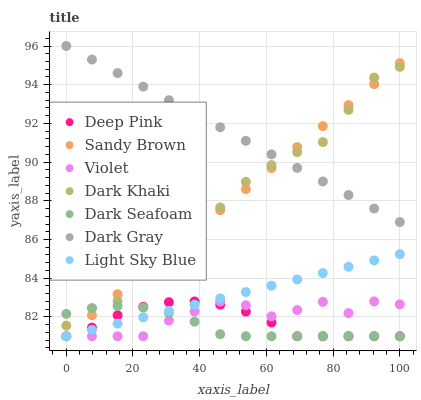Does Dark Seafoam have the minimum area under the curve?
Answer yes or no. Yes. Does Dark Gray have the maximum area under the curve?
Answer yes or no. Yes. Does Deep Pink have the minimum area under the curve?
Answer yes or no. No. Does Deep Pink have the maximum area under the curve?
Answer yes or no. No. Is Light Sky Blue the smoothest?
Answer yes or no. Yes. Is Dark Khaki the roughest?
Answer yes or no. Yes. Is Deep Pink the smoothest?
Answer yes or no. No. Is Deep Pink the roughest?
Answer yes or no. No. Does Deep Pink have the lowest value?
Answer yes or no. Yes. Does Dark Khaki have the lowest value?
Answer yes or no. No. Does Dark Gray have the highest value?
Answer yes or no. Yes. Does Deep Pink have the highest value?
Answer yes or no. No. Is Dark Seafoam less than Dark Gray?
Answer yes or no. Yes. Is Dark Gray greater than Light Sky Blue?
Answer yes or no. Yes. Does Deep Pink intersect Light Sky Blue?
Answer yes or no. Yes. Is Deep Pink less than Light Sky Blue?
Answer yes or no. No. Is Deep Pink greater than Light Sky Blue?
Answer yes or no. No. Does Dark Seafoam intersect Dark Gray?
Answer yes or no. No. 